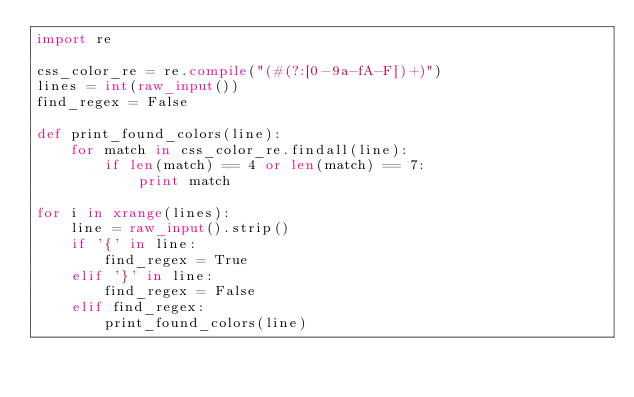Convert code to text. <code><loc_0><loc_0><loc_500><loc_500><_Python_>import re

css_color_re = re.compile("(#(?:[0-9a-fA-F])+)")
lines = int(raw_input())
find_regex = False

def print_found_colors(line):
    for match in css_color_re.findall(line):
        if len(match) == 4 or len(match) == 7:
            print match

for i in xrange(lines):
    line = raw_input().strip()
    if '{' in line:
        find_regex = True
    elif '}' in line:
        find_regex = False
    elif find_regex:
        print_found_colors(line)</code> 